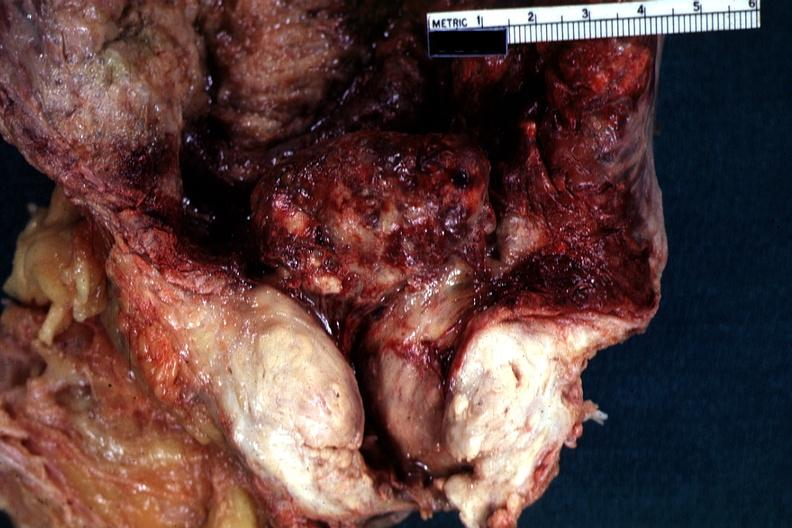what is present?
Answer the question using a single word or phrase. Prostate 